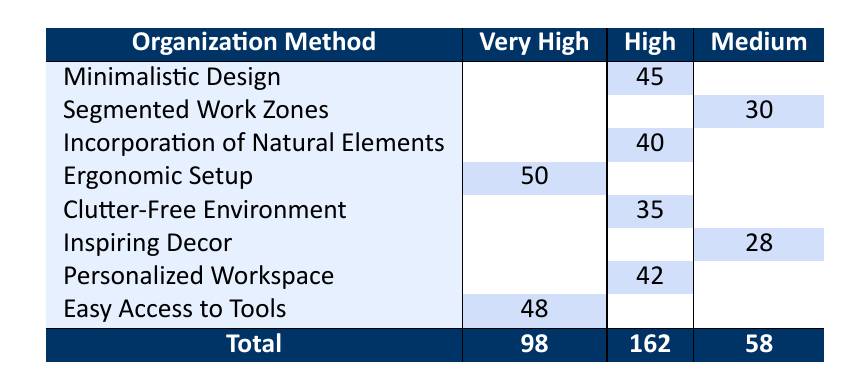What is the productivity rating for Ergonomic Setup? The table shows that "Ergonomic Setup" is categorized under the "Very High" productivity rating.
Answer: Very High How many video editors preferred the Minimalistic Design method? Looking at the row for "Minimalistic Design," it indicates that 45 video editors selected this organization method.
Answer: 45 Is the total number of video editors who rated their workspace as having a High productivity rating greater than those who rated it as Medium? The total for the High productivity rating is 162 (sum of 45, 40, 35, and 42), while the total for Medium is 58 (sum of 30, 28). Since 162 is greater than 58, the answer is yes.
Answer: Yes What is the total number of video editors that rated the organization methods with a Very High productivity rating? The table shows 50 (Ergonomic Setup) + 48 (Easy Access to Tools) = 98 video editors rated their workspaces as having a Very High productivity rating.
Answer: 98 Which organization method received the lowest count of video editors and what was the count? The method with the lowest count in the table is "Inspiring Decor" with a total of 28 video editors.
Answer: 28 What is the average number of video editors who rated each productivity level? To find the average, sum the totals (Very High: 98, High: 162, Medium: 58) = 318, then divide by 3 (average for three categories) giving approximately 106.
Answer: 106 Are there more organization methods rated as High compared to those rated as Medium? The table outlines 5 methods rated as High (Minimalistic Design, Incorporation of Natural Elements, Clutter-Free Environment, Personalized Workspace) and 3 methods rated as Medium (Segmented Work Zones, Inspiring Decor). Thus, there are more methods rated as High.
Answer: Yes What is the difference in the number of video editors who preferred Easy Access to Tools compared to Segmented Work Zones? Easy Access to Tools has 48 video editors while Segmented Work Zones has 30. The difference is 48 - 30 = 18.
Answer: 18 